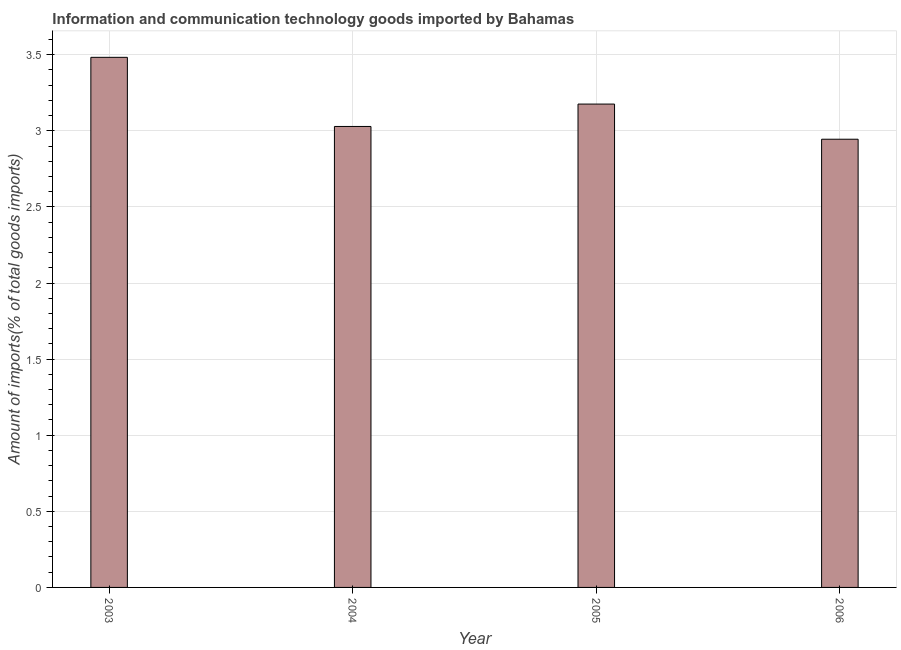Does the graph contain grids?
Offer a terse response. Yes. What is the title of the graph?
Keep it short and to the point. Information and communication technology goods imported by Bahamas. What is the label or title of the X-axis?
Make the answer very short. Year. What is the label or title of the Y-axis?
Offer a terse response. Amount of imports(% of total goods imports). What is the amount of ict goods imports in 2005?
Your answer should be very brief. 3.18. Across all years, what is the maximum amount of ict goods imports?
Provide a short and direct response. 3.48. Across all years, what is the minimum amount of ict goods imports?
Offer a very short reply. 2.94. What is the sum of the amount of ict goods imports?
Your answer should be compact. 12.63. What is the difference between the amount of ict goods imports in 2004 and 2006?
Your answer should be very brief. 0.08. What is the average amount of ict goods imports per year?
Keep it short and to the point. 3.16. What is the median amount of ict goods imports?
Your answer should be very brief. 3.1. What is the ratio of the amount of ict goods imports in 2003 to that in 2004?
Give a very brief answer. 1.15. Is the difference between the amount of ict goods imports in 2003 and 2005 greater than the difference between any two years?
Your response must be concise. No. What is the difference between the highest and the second highest amount of ict goods imports?
Give a very brief answer. 0.31. Is the sum of the amount of ict goods imports in 2003 and 2005 greater than the maximum amount of ict goods imports across all years?
Provide a succinct answer. Yes. What is the difference between the highest and the lowest amount of ict goods imports?
Ensure brevity in your answer.  0.54. In how many years, is the amount of ict goods imports greater than the average amount of ict goods imports taken over all years?
Make the answer very short. 2. Are all the bars in the graph horizontal?
Your answer should be very brief. No. What is the Amount of imports(% of total goods imports) of 2003?
Your response must be concise. 3.48. What is the Amount of imports(% of total goods imports) of 2004?
Provide a short and direct response. 3.03. What is the Amount of imports(% of total goods imports) in 2005?
Your response must be concise. 3.18. What is the Amount of imports(% of total goods imports) of 2006?
Offer a very short reply. 2.94. What is the difference between the Amount of imports(% of total goods imports) in 2003 and 2004?
Offer a terse response. 0.45. What is the difference between the Amount of imports(% of total goods imports) in 2003 and 2005?
Give a very brief answer. 0.31. What is the difference between the Amount of imports(% of total goods imports) in 2003 and 2006?
Provide a short and direct response. 0.54. What is the difference between the Amount of imports(% of total goods imports) in 2004 and 2005?
Offer a terse response. -0.15. What is the difference between the Amount of imports(% of total goods imports) in 2004 and 2006?
Ensure brevity in your answer.  0.08. What is the difference between the Amount of imports(% of total goods imports) in 2005 and 2006?
Provide a succinct answer. 0.23. What is the ratio of the Amount of imports(% of total goods imports) in 2003 to that in 2004?
Your response must be concise. 1.15. What is the ratio of the Amount of imports(% of total goods imports) in 2003 to that in 2005?
Offer a very short reply. 1.1. What is the ratio of the Amount of imports(% of total goods imports) in 2003 to that in 2006?
Offer a terse response. 1.18. What is the ratio of the Amount of imports(% of total goods imports) in 2004 to that in 2005?
Offer a terse response. 0.95. What is the ratio of the Amount of imports(% of total goods imports) in 2004 to that in 2006?
Offer a terse response. 1.03. What is the ratio of the Amount of imports(% of total goods imports) in 2005 to that in 2006?
Provide a succinct answer. 1.08. 